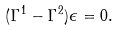<formula> <loc_0><loc_0><loc_500><loc_500>( \Gamma ^ { 1 } - \Gamma ^ { 2 } ) \epsilon = 0 .</formula> 